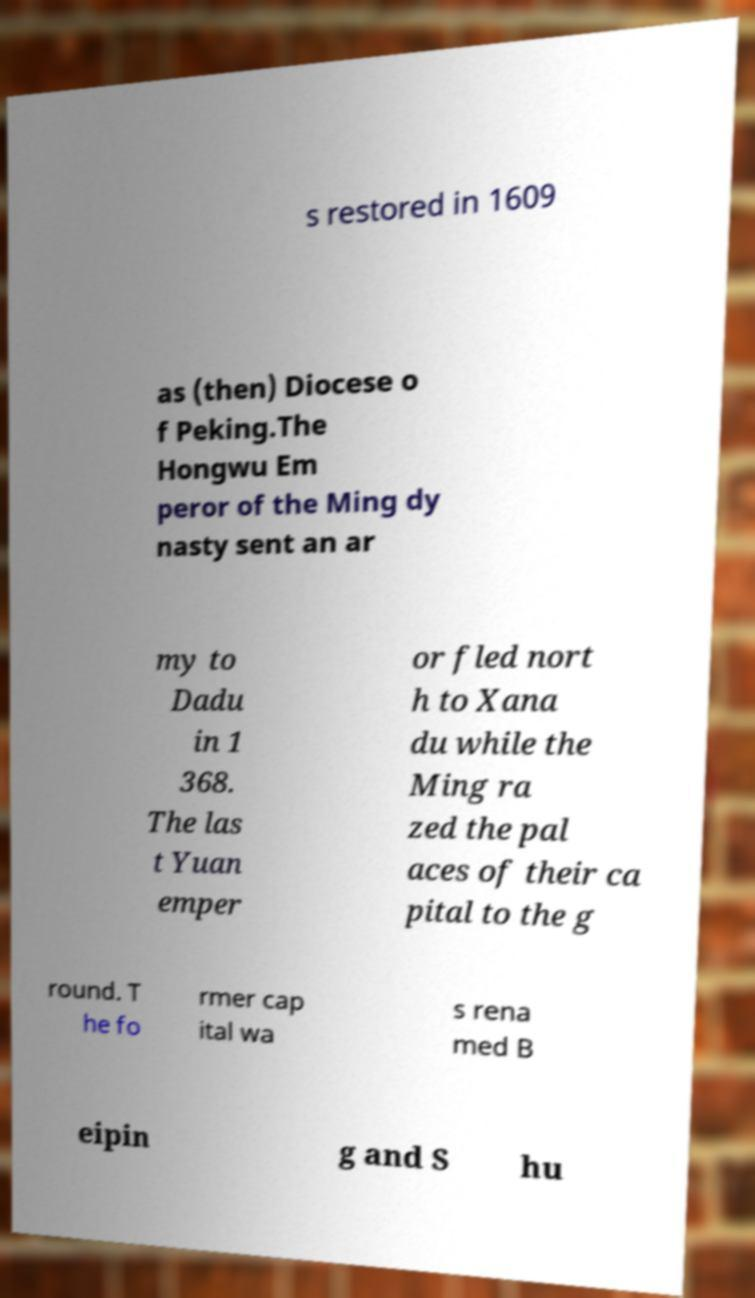What messages or text are displayed in this image? I need them in a readable, typed format. s restored in 1609 as (then) Diocese o f Peking.The Hongwu Em peror of the Ming dy nasty sent an ar my to Dadu in 1 368. The las t Yuan emper or fled nort h to Xana du while the Ming ra zed the pal aces of their ca pital to the g round. T he fo rmer cap ital wa s rena med B eipin g and S hu 